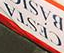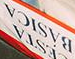Read the text from these images in sequence, separated by a semicolon. CESTA; BÁSICA 